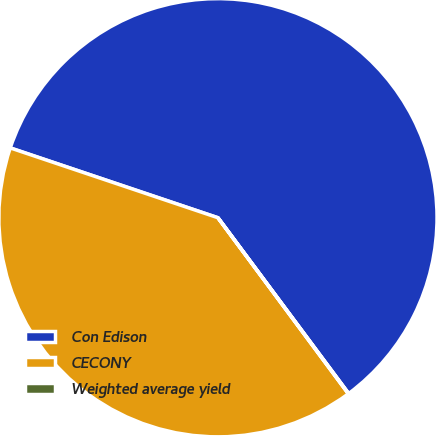Convert chart to OTSL. <chart><loc_0><loc_0><loc_500><loc_500><pie_chart><fcel>Con Edison<fcel>CECONY<fcel>Weighted average yield<nl><fcel>59.66%<fcel>40.31%<fcel>0.03%<nl></chart> 